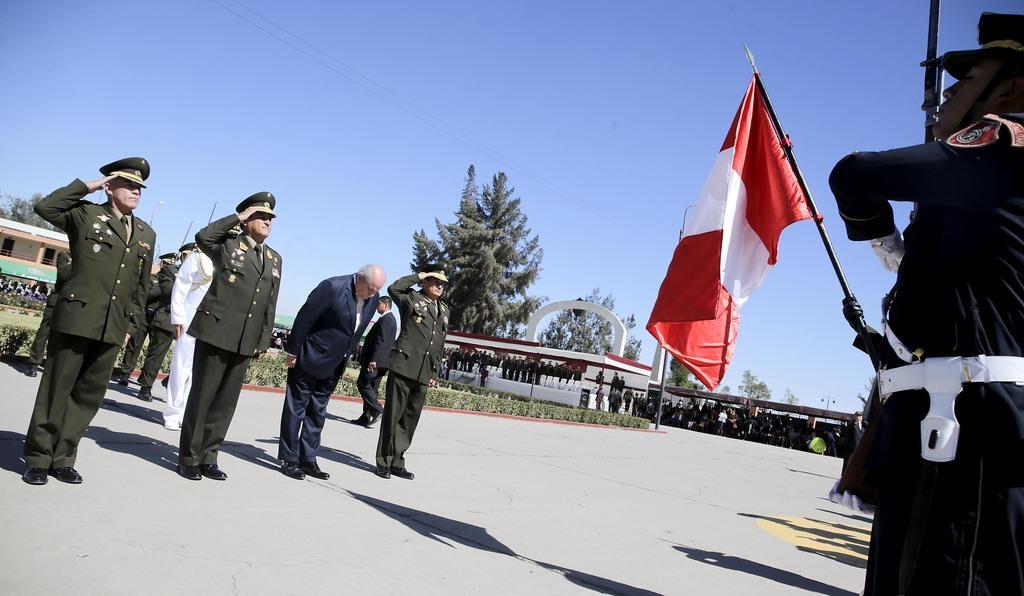Please provide a concise description of this image. In this image, we can see few people. Here we can see three people are doing salute on the path. On the right side, we can see a person, flag and pole. Background we can see a group of people, plants, trees, shed, tent and building. Here there is a sky. 